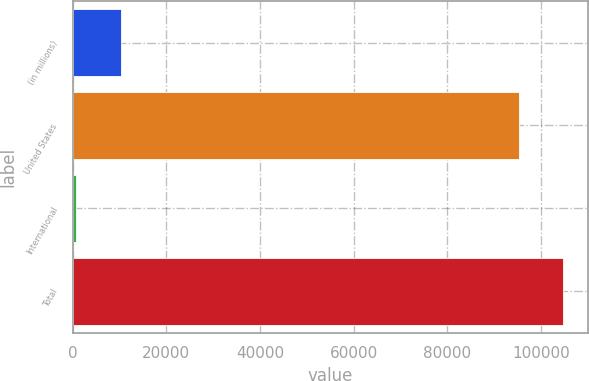Convert chart. <chart><loc_0><loc_0><loc_500><loc_500><bar_chart><fcel>(in millions)<fcel>United States<fcel>International<fcel>Total<nl><fcel>10268.1<fcel>95248.2<fcel>743.3<fcel>104773<nl></chart> 